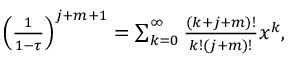<formula> <loc_0><loc_0><loc_500><loc_500>\begin{array} { r } { \left ( \frac { 1 } { 1 - \tau } \right ) ^ { j + m + 1 } = \sum _ { k = 0 } ^ { \infty } \frac { ( k + j + m ) ! } { k ! ( j + m ) ! } x ^ { k } , } \end{array}</formula> 